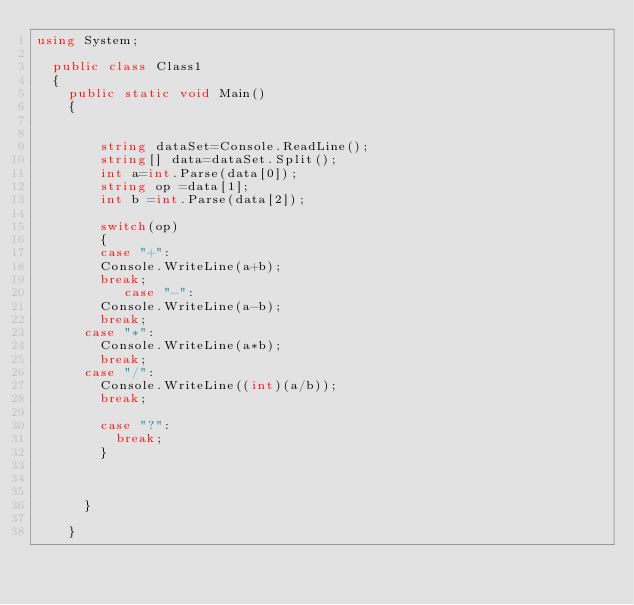Convert code to text. <code><loc_0><loc_0><loc_500><loc_500><_C#_>using System;

	public class Class1
	{
		public static void Main()
		{   
		
			
				string dataSet=Console.ReadLine();
				string[] data=dataSet.Split();
				int a=int.Parse(data[0]);
				string op =data[1];
				int b =int.Parse(data[2]);
		
				switch(op)
				{
				case "+":
				Console.WriteLine(a+b);
				break;
			     case "-":
				Console.WriteLine(a-b);
				break;
			case "*":
				Console.WriteLine(a*b);
				break;
			case "/":
				Console.WriteLine((int)(a/b));
				break;
				
				case "?":
					break;
				}
					
			    
				
			}
			
		}
	</code> 